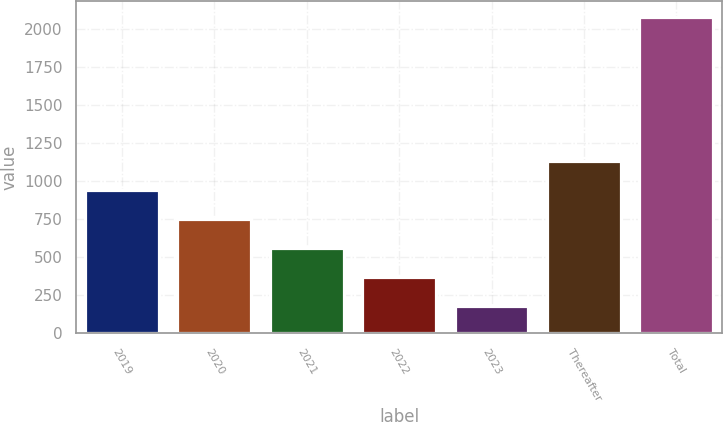Convert chart to OTSL. <chart><loc_0><loc_0><loc_500><loc_500><bar_chart><fcel>2019<fcel>2020<fcel>2021<fcel>2022<fcel>2023<fcel>Thereafter<fcel>Total<nl><fcel>942.92<fcel>753.04<fcel>563.16<fcel>373.28<fcel>183.4<fcel>1132.8<fcel>2082.2<nl></chart> 